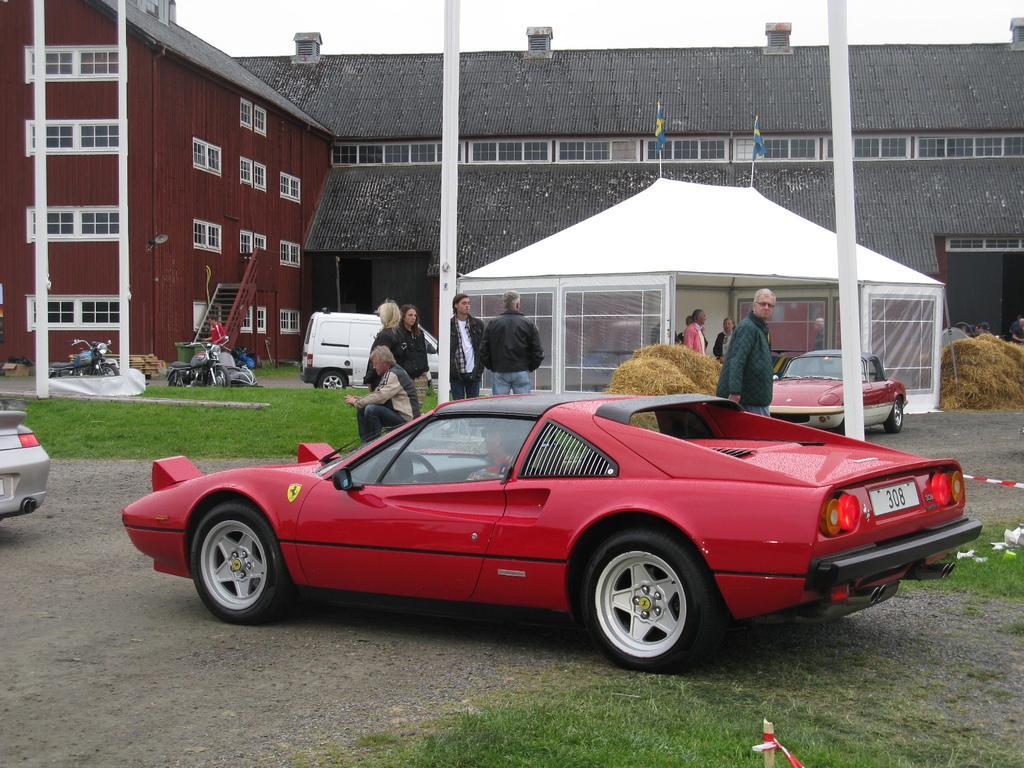Can you describe this image briefly? In this picture there is a man who is sitting inside the red car. Beside the car we can see old man who is wearing goggle, jacket and trouser. In the center we can see the group of persons were standing near to the pole. On the left there is a man who is wearing red t-shirt and trouser. He is standing near to the dustbin, bikes and plastic covers. In the background we can see the building and tent. At the top of the text there are two flags. In front of that we can see a group of persons were standing near to the grass and red car. At the bottom we can see green grass. At the top there is a sky. 